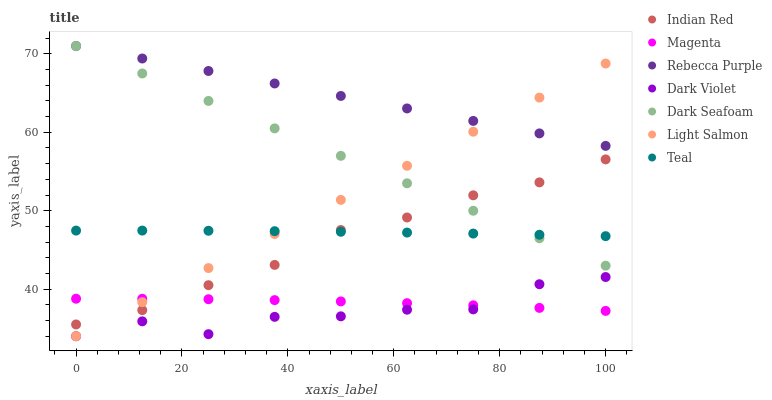Does Dark Violet have the minimum area under the curve?
Answer yes or no. Yes. Does Rebecca Purple have the maximum area under the curve?
Answer yes or no. Yes. Does Teal have the minimum area under the curve?
Answer yes or no. No. Does Teal have the maximum area under the curve?
Answer yes or no. No. Is Light Salmon the smoothest?
Answer yes or no. Yes. Is Dark Violet the roughest?
Answer yes or no. Yes. Is Teal the smoothest?
Answer yes or no. No. Is Teal the roughest?
Answer yes or no. No. Does Light Salmon have the lowest value?
Answer yes or no. Yes. Does Teal have the lowest value?
Answer yes or no. No. Does Rebecca Purple have the highest value?
Answer yes or no. Yes. Does Teal have the highest value?
Answer yes or no. No. Is Magenta less than Rebecca Purple?
Answer yes or no. Yes. Is Rebecca Purple greater than Indian Red?
Answer yes or no. Yes. Does Light Salmon intersect Dark Seafoam?
Answer yes or no. Yes. Is Light Salmon less than Dark Seafoam?
Answer yes or no. No. Is Light Salmon greater than Dark Seafoam?
Answer yes or no. No. Does Magenta intersect Rebecca Purple?
Answer yes or no. No. 